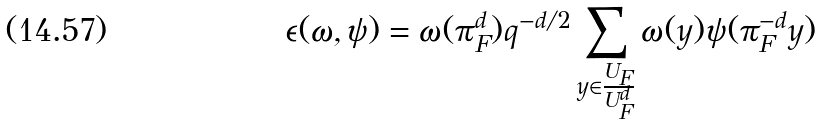Convert formula to latex. <formula><loc_0><loc_0><loc_500><loc_500>\epsilon ( \omega , \psi ) = \omega ( \pi _ { F } ^ { d } ) q ^ { - d / 2 } \sum _ { y \in \frac { U _ { F } } { U _ { F } ^ { d } } } \omega ( y ) \psi ( \pi _ { F } ^ { - d } y )</formula> 